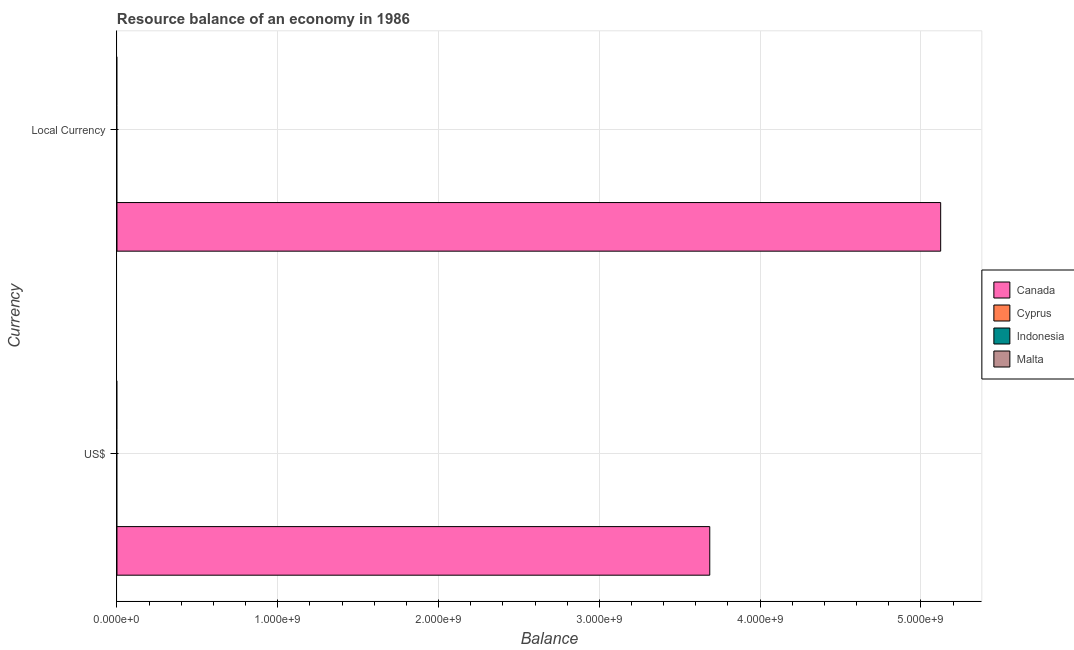Are the number of bars per tick equal to the number of legend labels?
Make the answer very short. No. Are the number of bars on each tick of the Y-axis equal?
Keep it short and to the point. Yes. How many bars are there on the 2nd tick from the top?
Provide a short and direct response. 1. How many bars are there on the 2nd tick from the bottom?
Give a very brief answer. 1. What is the label of the 2nd group of bars from the top?
Provide a short and direct response. US$. What is the resource balance in constant us$ in Canada?
Offer a terse response. 5.12e+09. Across all countries, what is the maximum resource balance in constant us$?
Offer a very short reply. 5.12e+09. Across all countries, what is the minimum resource balance in constant us$?
Offer a very short reply. 0. What is the total resource balance in constant us$ in the graph?
Provide a short and direct response. 5.12e+09. What is the average resource balance in us$ per country?
Make the answer very short. 9.22e+08. What is the difference between the resource balance in constant us$ and resource balance in us$ in Canada?
Give a very brief answer. 1.44e+09. In how many countries, is the resource balance in us$ greater than 3800000000 units?
Make the answer very short. 0. In how many countries, is the resource balance in us$ greater than the average resource balance in us$ taken over all countries?
Give a very brief answer. 1. How many bars are there?
Ensure brevity in your answer.  2. Are the values on the major ticks of X-axis written in scientific E-notation?
Offer a terse response. Yes. Does the graph contain grids?
Give a very brief answer. Yes. Where does the legend appear in the graph?
Give a very brief answer. Center right. How many legend labels are there?
Provide a short and direct response. 4. What is the title of the graph?
Ensure brevity in your answer.  Resource balance of an economy in 1986. Does "Bahrain" appear as one of the legend labels in the graph?
Give a very brief answer. No. What is the label or title of the X-axis?
Ensure brevity in your answer.  Balance. What is the label or title of the Y-axis?
Your response must be concise. Currency. What is the Balance of Canada in US$?
Ensure brevity in your answer.  3.69e+09. What is the Balance of Malta in US$?
Offer a very short reply. 0. What is the Balance of Canada in Local Currency?
Provide a short and direct response. 5.12e+09. What is the Balance in Cyprus in Local Currency?
Make the answer very short. 0. What is the Balance of Indonesia in Local Currency?
Your answer should be compact. 0. What is the Balance of Malta in Local Currency?
Provide a succinct answer. 0. Across all Currency, what is the maximum Balance in Canada?
Give a very brief answer. 5.12e+09. Across all Currency, what is the minimum Balance of Canada?
Make the answer very short. 3.69e+09. What is the total Balance in Canada in the graph?
Your response must be concise. 8.81e+09. What is the total Balance of Malta in the graph?
Your response must be concise. 0. What is the difference between the Balance of Canada in US$ and that in Local Currency?
Give a very brief answer. -1.44e+09. What is the average Balance of Canada per Currency?
Offer a terse response. 4.40e+09. What is the ratio of the Balance of Canada in US$ to that in Local Currency?
Your response must be concise. 0.72. What is the difference between the highest and the second highest Balance in Canada?
Ensure brevity in your answer.  1.44e+09. What is the difference between the highest and the lowest Balance in Canada?
Keep it short and to the point. 1.44e+09. 